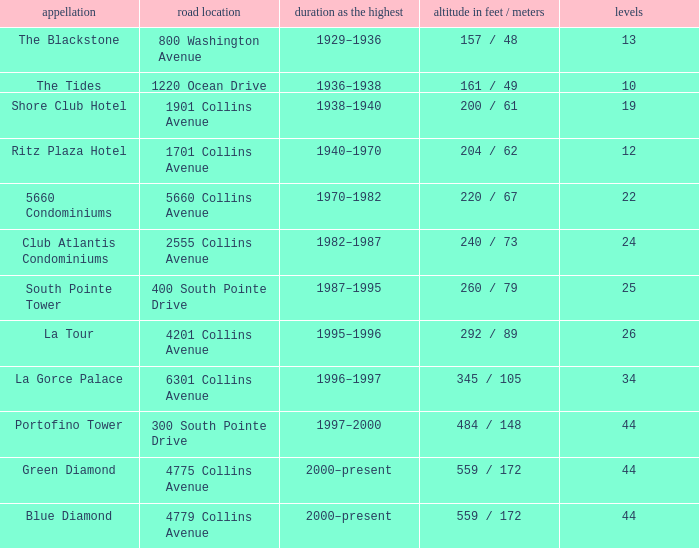How many years was the building with 24 floors the tallest? 1982–1987. Could you parse the entire table? {'header': ['appellation', 'road location', 'duration as the highest', 'altitude in feet / meters', 'levels'], 'rows': [['The Blackstone', '800 Washington Avenue', '1929–1936', '157 / 48', '13'], ['The Tides', '1220 Ocean Drive', '1936–1938', '161 / 49', '10'], ['Shore Club Hotel', '1901 Collins Avenue', '1938–1940', '200 / 61', '19'], ['Ritz Plaza Hotel', '1701 Collins Avenue', '1940–1970', '204 / 62', '12'], ['5660 Condominiums', '5660 Collins Avenue', '1970–1982', '220 / 67', '22'], ['Club Atlantis Condominiums', '2555 Collins Avenue', '1982–1987', '240 / 73', '24'], ['South Pointe Tower', '400 South Pointe Drive', '1987–1995', '260 / 79', '25'], ['La Tour', '4201 Collins Avenue', '1995–1996', '292 / 89', '26'], ['La Gorce Palace', '6301 Collins Avenue', '1996–1997', '345 / 105', '34'], ['Portofino Tower', '300 South Pointe Drive', '1997–2000', '484 / 148', '44'], ['Green Diamond', '4775 Collins Avenue', '2000–present', '559 / 172', '44'], ['Blue Diamond', '4779 Collins Avenue', '2000–present', '559 / 172', '44']]} 